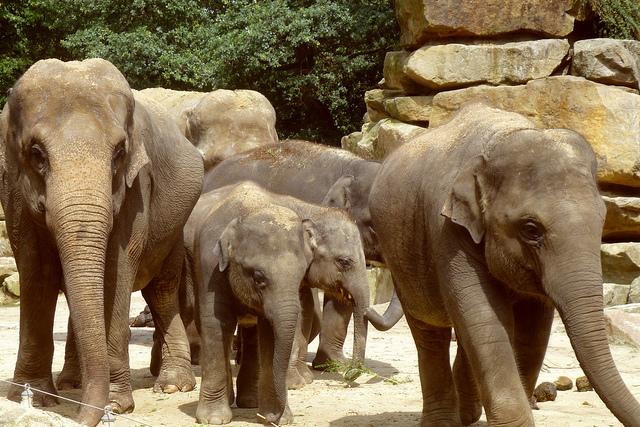What are the three small objects on the ground?
Give a very brief answer. Rocks. Do these animals have ivory?
Write a very short answer. No. How many elephants are young?
Write a very short answer. 3. What kind of animal is shown?
Give a very brief answer. Elephant. 